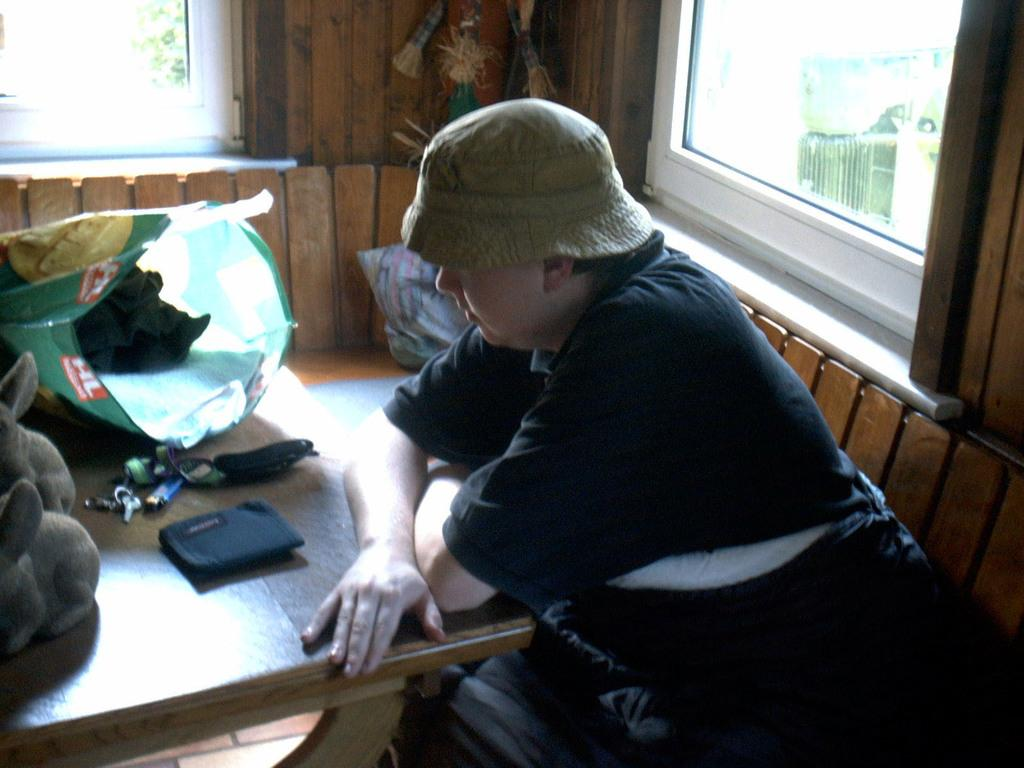What can be seen in the background of the image? A: There are windows in the background of the image. What is the person in the image doing? The person is sitting on a chair in the image. What is the person sitting in front of? The person is in front of a table. What items are on the table? There is a bag, a wallet, keys, a lighter, and dolls on the table. Can you see any horses in the image? No, there are no horses present in the image. What type of crack is visible on the table in the image? There is no crack visible on the table in the image. 